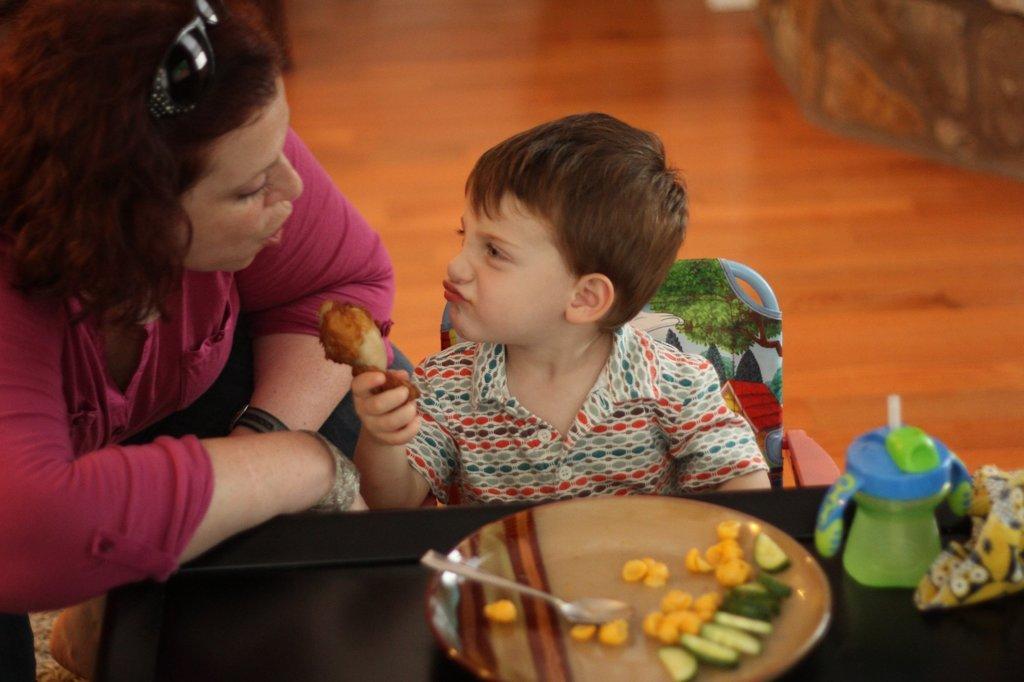How would you summarize this image in a sentence or two? In this image I can see a woman and I can see a boy is sitting on a chair. I can see he is holding a brown colour thing. I can also see a plate, a bottle, food and a spoon over here. 